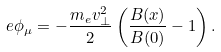<formula> <loc_0><loc_0><loc_500><loc_500>e \phi _ { \mu } = - \frac { m _ { e } v _ { \perp } ^ { 2 } } { 2 } \left ( \frac { B ( x ) } { B ( 0 ) } - 1 \right ) .</formula> 